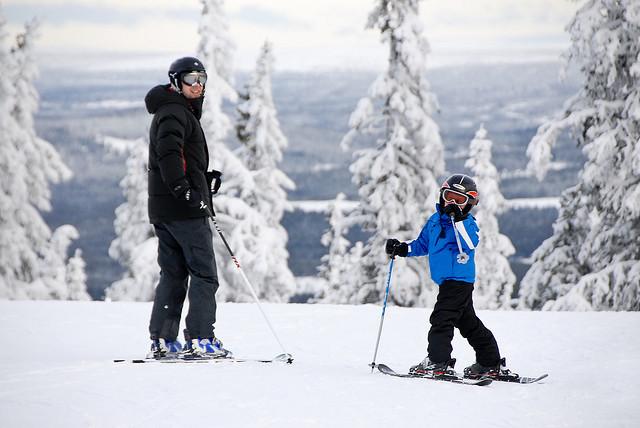Are they on vacation?
Concise answer only. Yes. Are these people male or female?
Quick response, please. Male. What is covering the trees in the background?
Short answer required. Snow. 